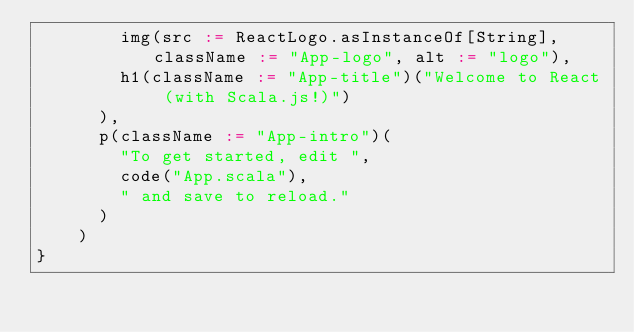<code> <loc_0><loc_0><loc_500><loc_500><_Scala_>        img(src := ReactLogo.asInstanceOf[String], className := "App-logo", alt := "logo"),
        h1(className := "App-title")("Welcome to React (with Scala.js!)")
      ),
      p(className := "App-intro")(
        "To get started, edit ",
        code("App.scala"),
        " and save to reload."
      )
    )
}
</code> 